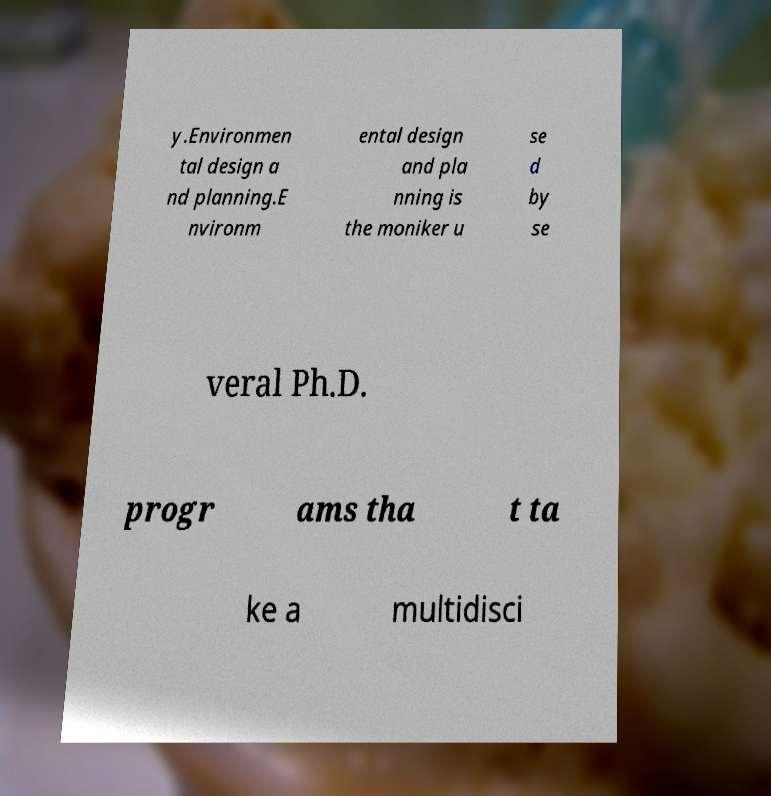Could you extract and type out the text from this image? y.Environmen tal design a nd planning.E nvironm ental design and pla nning is the moniker u se d by se veral Ph.D. progr ams tha t ta ke a multidisci 